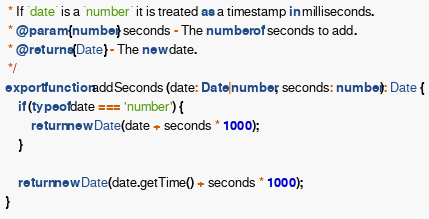<code> <loc_0><loc_0><loc_500><loc_500><_TypeScript_> * If `date` is a `number` it is treated as a timestamp in milliseconds.
 * @param {number} seconds - The number of seconds to add.
 * @returns {Date} - The new date.
 */
export function addSeconds (date: Date|number, seconds: number): Date {
	if (typeof date === 'number') {
		return new Date(date + seconds * 1000);
	}

	return new Date(date.getTime() + seconds * 1000);
}
</code> 